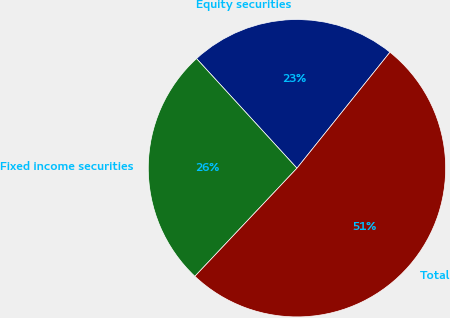Convert chart. <chart><loc_0><loc_0><loc_500><loc_500><pie_chart><fcel>Equity securities<fcel>Fixed income securities<fcel>Total<nl><fcel>22.56%<fcel>26.15%<fcel>51.28%<nl></chart> 